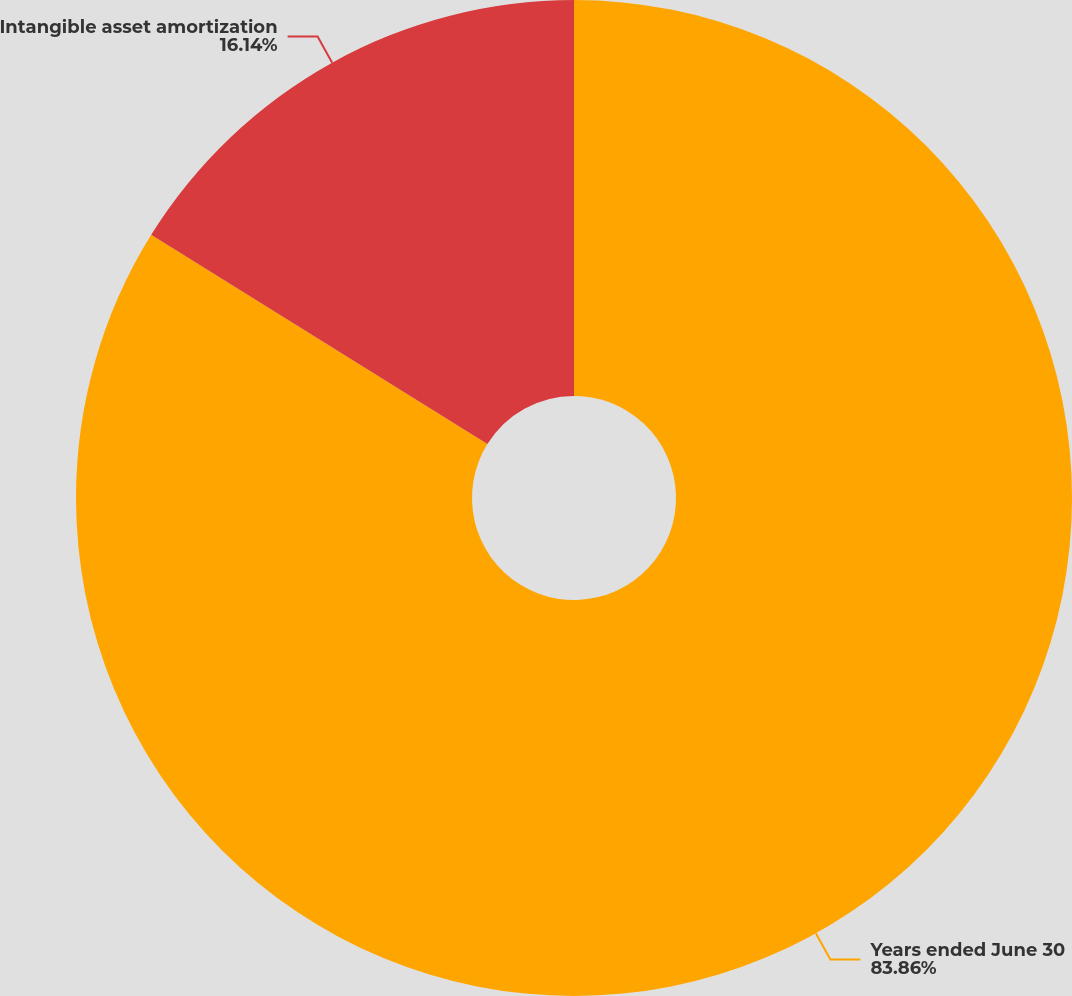<chart> <loc_0><loc_0><loc_500><loc_500><pie_chart><fcel>Years ended June 30<fcel>Intangible asset amortization<nl><fcel>83.86%<fcel>16.14%<nl></chart> 